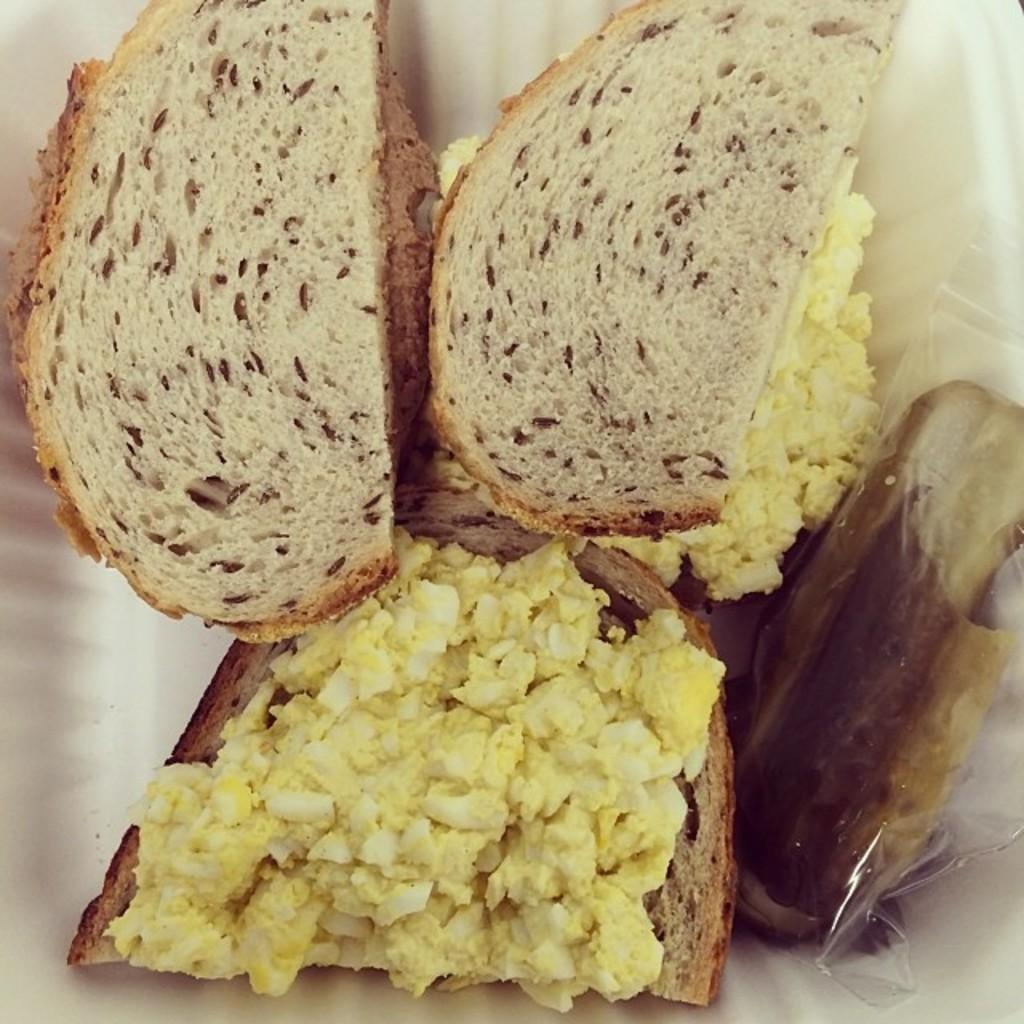What types of food items can be seen in the image? The specific types of food items are not mentioned, but there are food items present in the image. What is the color of the surface the food items are placed on? The surface the food items are on is white in color. How many straws are present in the image? There is no mention of straws in the image, so we cannot determine the number of straws present. 